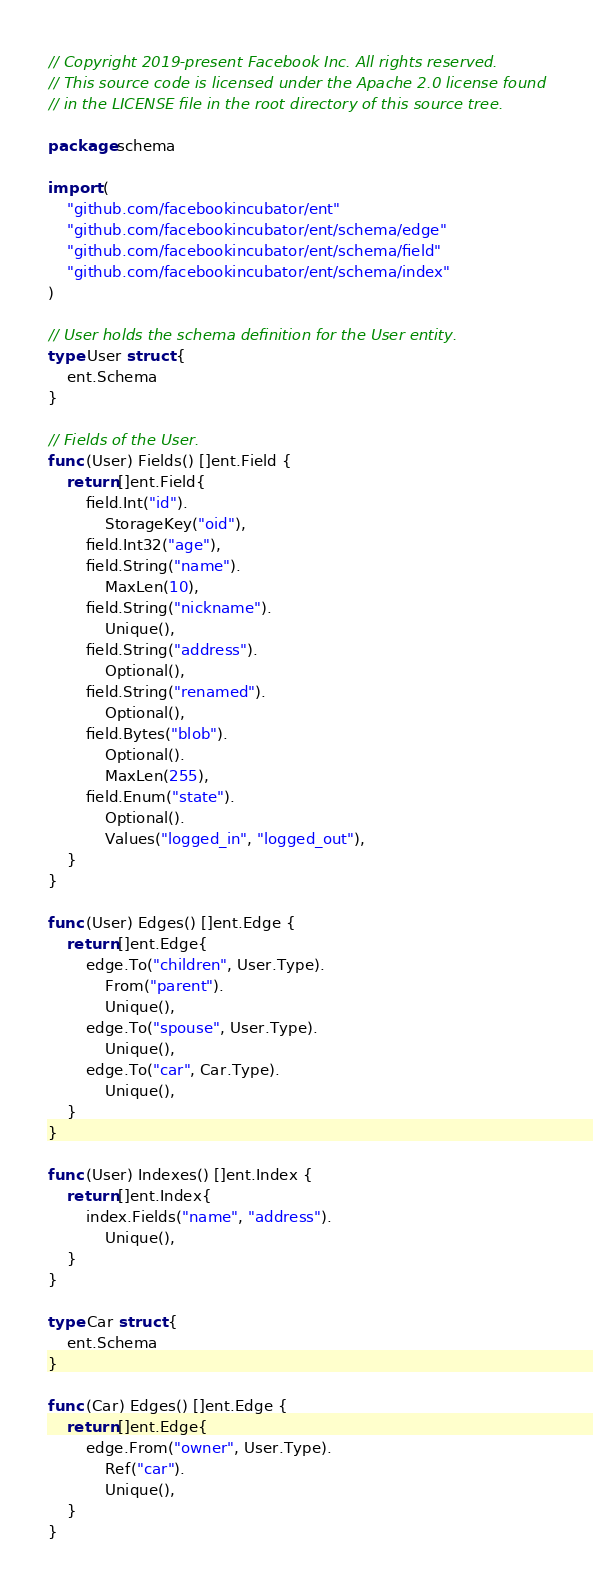<code> <loc_0><loc_0><loc_500><loc_500><_Go_>// Copyright 2019-present Facebook Inc. All rights reserved.
// This source code is licensed under the Apache 2.0 license found
// in the LICENSE file in the root directory of this source tree.

package schema

import (
	"github.com/facebookincubator/ent"
	"github.com/facebookincubator/ent/schema/edge"
	"github.com/facebookincubator/ent/schema/field"
	"github.com/facebookincubator/ent/schema/index"
)

// User holds the schema definition for the User entity.
type User struct {
	ent.Schema
}

// Fields of the User.
func (User) Fields() []ent.Field {
	return []ent.Field{
		field.Int("id").
			StorageKey("oid"),
		field.Int32("age"),
		field.String("name").
			MaxLen(10),
		field.String("nickname").
			Unique(),
		field.String("address").
			Optional(),
		field.String("renamed").
			Optional(),
		field.Bytes("blob").
			Optional().
			MaxLen(255),
		field.Enum("state").
			Optional().
			Values("logged_in", "logged_out"),
	}
}

func (User) Edges() []ent.Edge {
	return []ent.Edge{
		edge.To("children", User.Type).
			From("parent").
			Unique(),
		edge.To("spouse", User.Type).
			Unique(),
		edge.To("car", Car.Type).
			Unique(),
	}
}

func (User) Indexes() []ent.Index {
	return []ent.Index{
		index.Fields("name", "address").
			Unique(),
	}
}

type Car struct {
	ent.Schema
}

func (Car) Edges() []ent.Edge {
	return []ent.Edge{
		edge.From("owner", User.Type).
			Ref("car").
			Unique(),
	}
}
</code> 